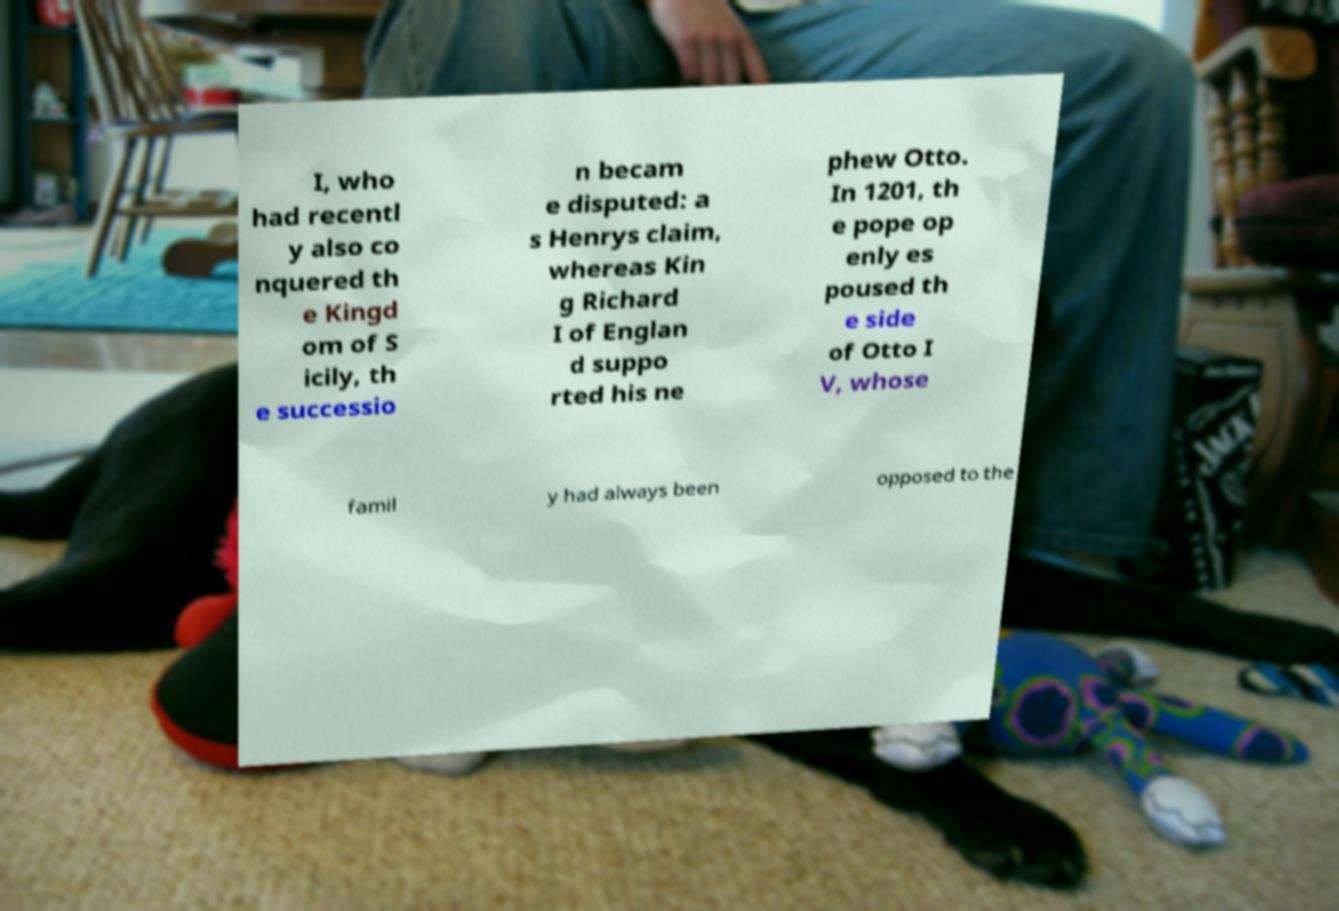Can you accurately transcribe the text from the provided image for me? I, who had recentl y also co nquered th e Kingd om of S icily, th e successio n becam e disputed: a s Henrys claim, whereas Kin g Richard I of Englan d suppo rted his ne phew Otto. In 1201, th e pope op enly es poused th e side of Otto I V, whose famil y had always been opposed to the 